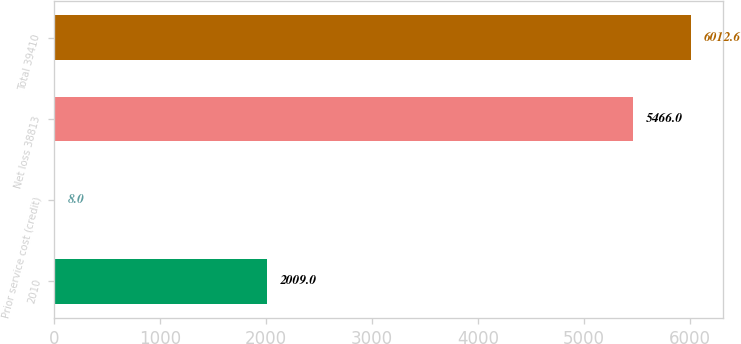Convert chart. <chart><loc_0><loc_0><loc_500><loc_500><bar_chart><fcel>2010<fcel>Prior service cost (credit)<fcel>Net loss 38813<fcel>Total 39410<nl><fcel>2009<fcel>8<fcel>5466<fcel>6012.6<nl></chart> 